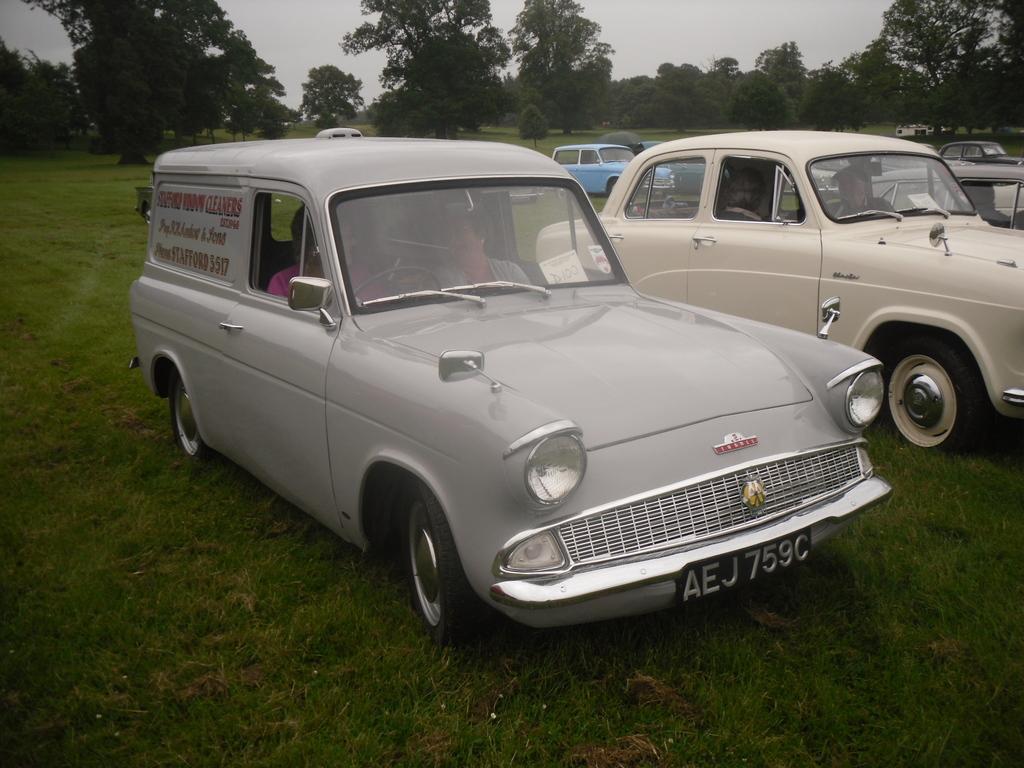In one or two sentences, can you explain what this image depicts? Land is covered with grass. Here we can see vehicles. People are sitting inside vehicles. Background there are a number of trees. 